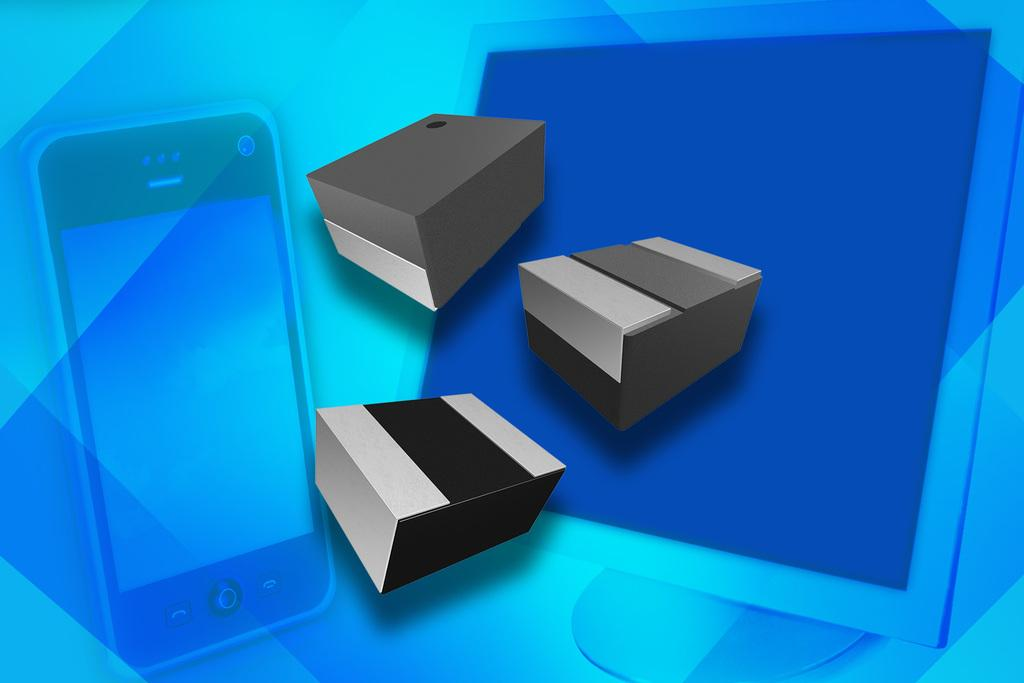How many boxes are present in the image? There are three boxes in the image. What are the colors of the boxes? The boxes are grey, silver, and black in color. What is the color of the background in the image? The background in the image is blue. What other objects are visible on the blue background? A mobile and a monitor are visible on the blue background. Can you see any gardens in the image? No, there are no gardens present in the image. 